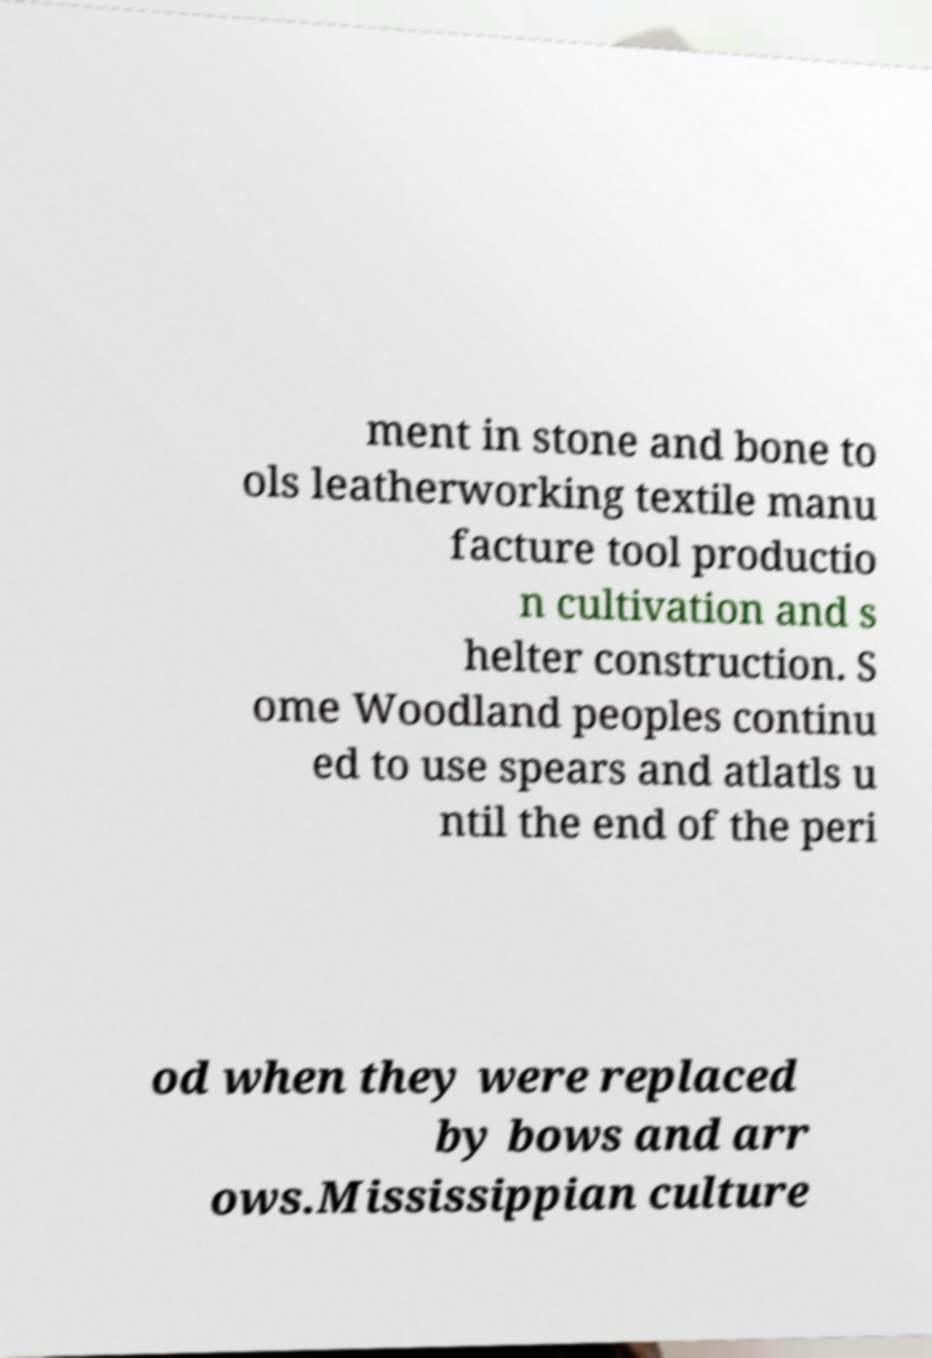Please identify and transcribe the text found in this image. ment in stone and bone to ols leatherworking textile manu facture tool productio n cultivation and s helter construction. S ome Woodland peoples continu ed to use spears and atlatls u ntil the end of the peri od when they were replaced by bows and arr ows.Mississippian culture 